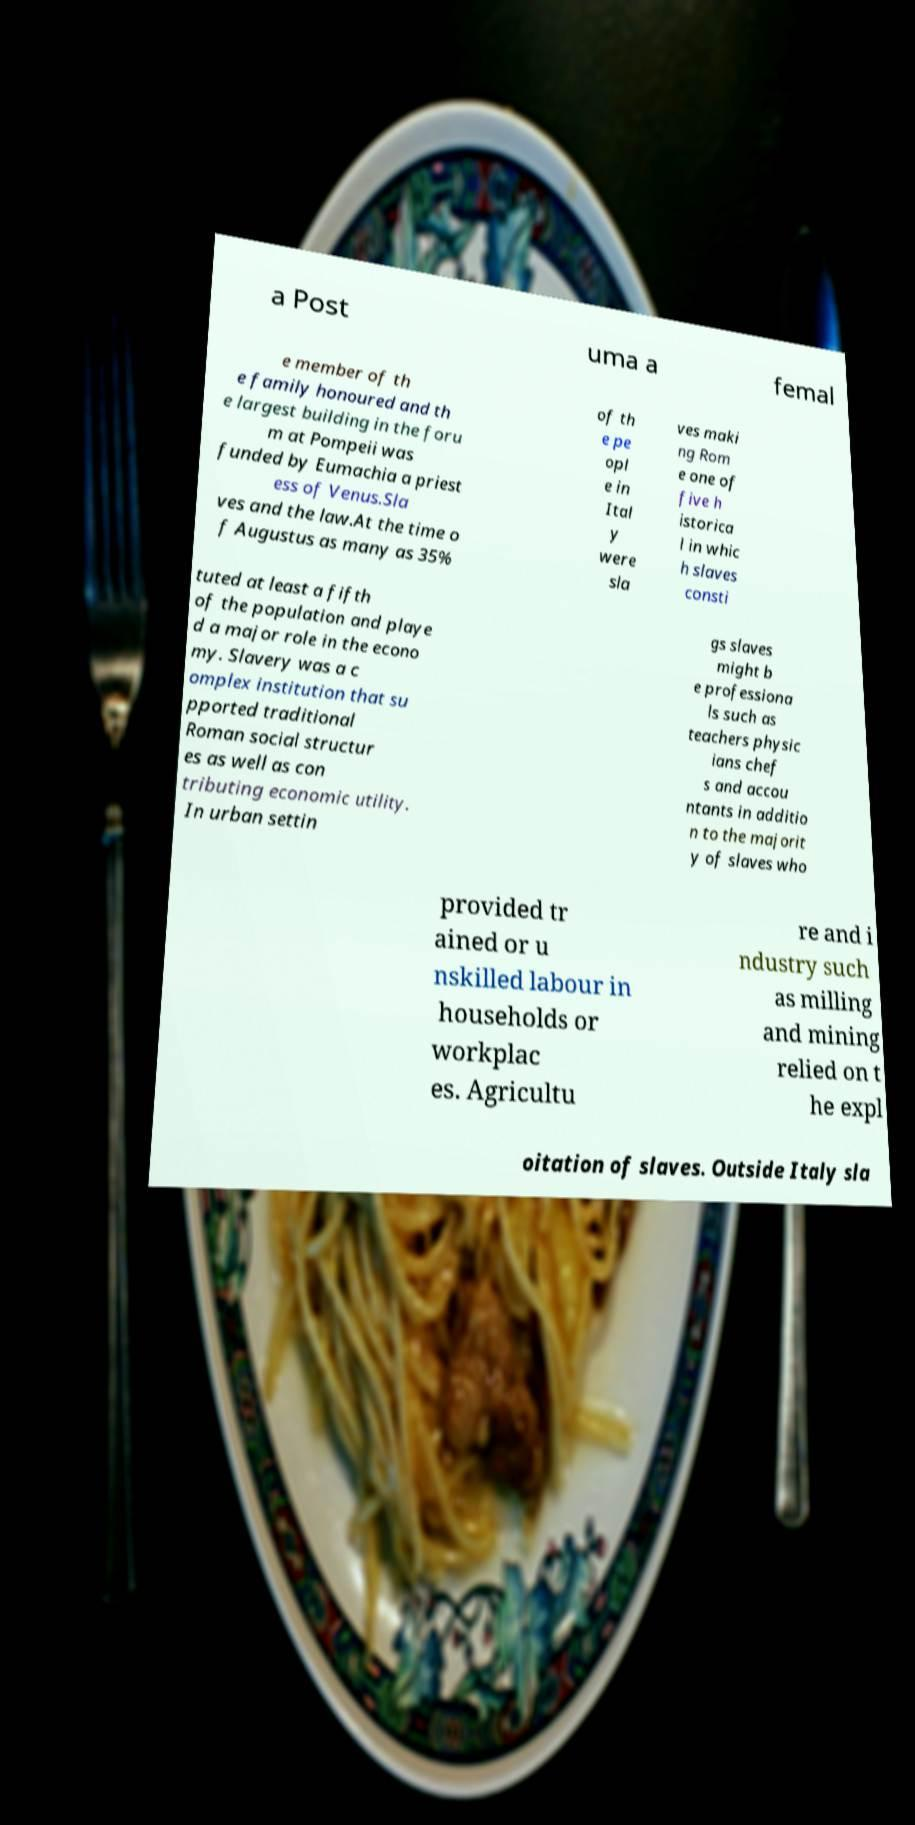Can you read and provide the text displayed in the image?This photo seems to have some interesting text. Can you extract and type it out for me? a Post uma a femal e member of th e family honoured and th e largest building in the foru m at Pompeii was funded by Eumachia a priest ess of Venus.Sla ves and the law.At the time o f Augustus as many as 35% of th e pe opl e in Ital y were sla ves maki ng Rom e one of five h istorica l in whic h slaves consti tuted at least a fifth of the population and playe d a major role in the econo my. Slavery was a c omplex institution that su pported traditional Roman social structur es as well as con tributing economic utility. In urban settin gs slaves might b e professiona ls such as teachers physic ians chef s and accou ntants in additio n to the majorit y of slaves who provided tr ained or u nskilled labour in households or workplac es. Agricultu re and i ndustry such as milling and mining relied on t he expl oitation of slaves. Outside Italy sla 